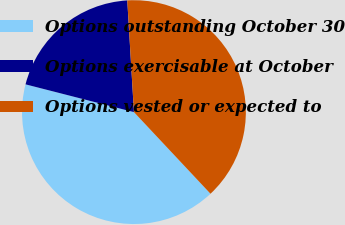Convert chart to OTSL. <chart><loc_0><loc_0><loc_500><loc_500><pie_chart><fcel>Options outstanding October 30<fcel>Options exercisable at October<fcel>Options vested or expected to<nl><fcel>40.98%<fcel>20.06%<fcel>38.96%<nl></chart> 